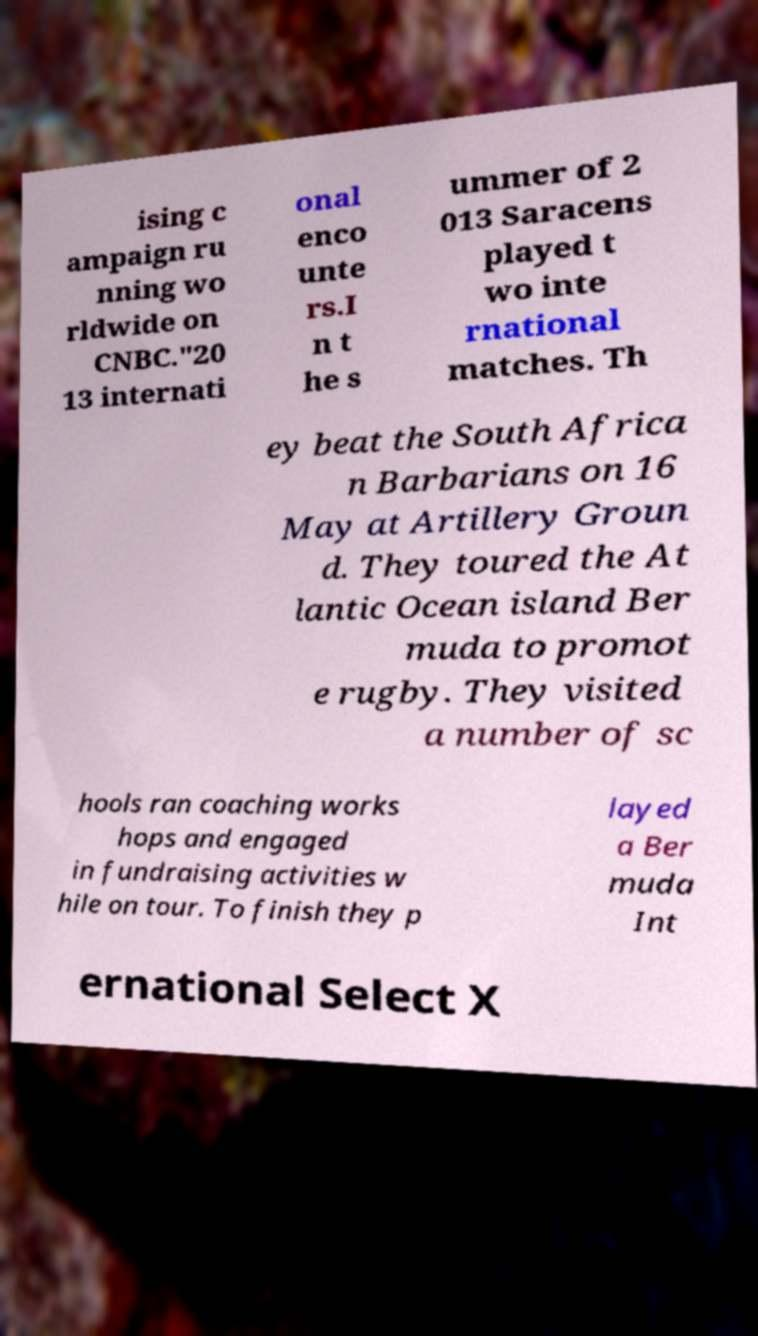Can you accurately transcribe the text from the provided image for me? ising c ampaign ru nning wo rldwide on CNBC."20 13 internati onal enco unte rs.I n t he s ummer of 2 013 Saracens played t wo inte rnational matches. Th ey beat the South Africa n Barbarians on 16 May at Artillery Groun d. They toured the At lantic Ocean island Ber muda to promot e rugby. They visited a number of sc hools ran coaching works hops and engaged in fundraising activities w hile on tour. To finish they p layed a Ber muda Int ernational Select X 